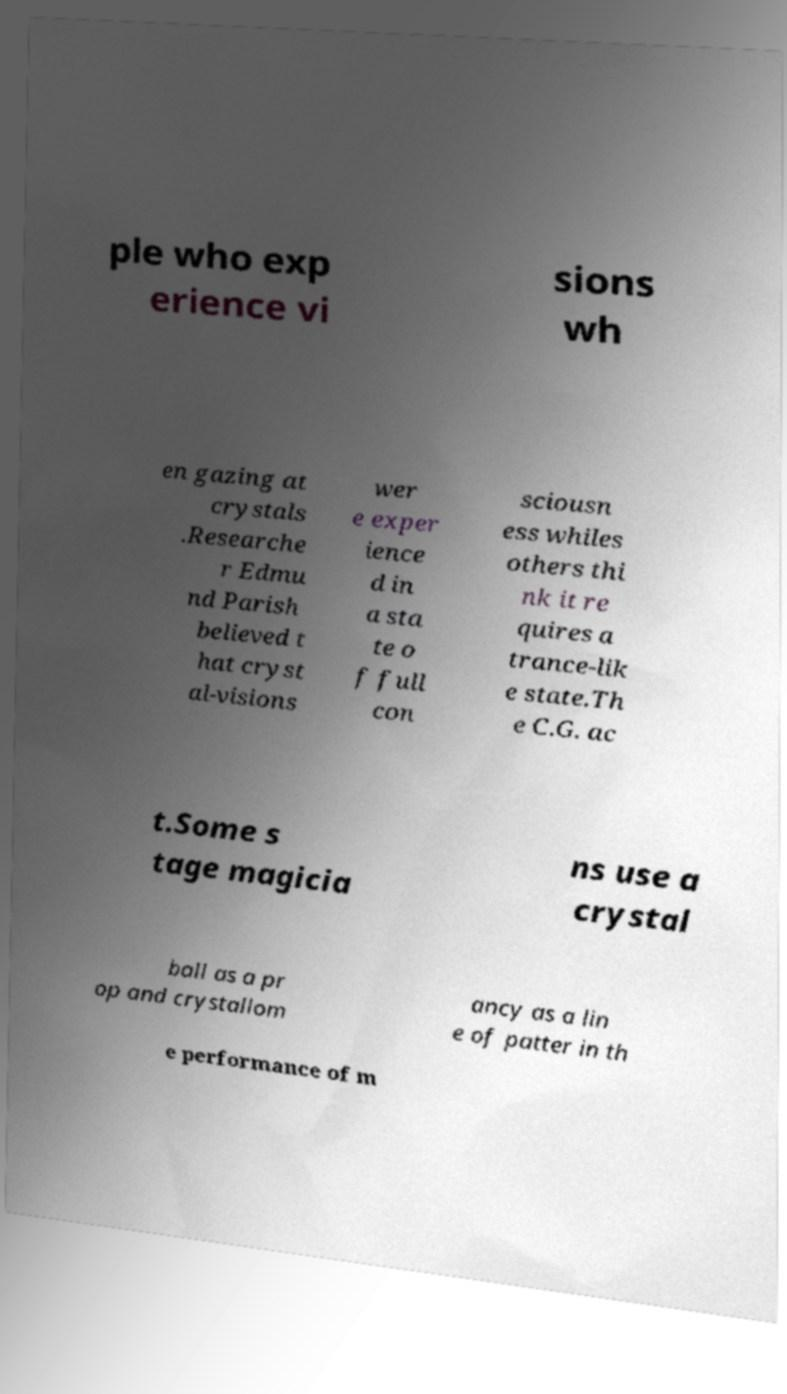Can you read and provide the text displayed in the image?This photo seems to have some interesting text. Can you extract and type it out for me? ple who exp erience vi sions wh en gazing at crystals .Researche r Edmu nd Parish believed t hat cryst al-visions wer e exper ience d in a sta te o f full con sciousn ess whiles others thi nk it re quires a trance-lik e state.Th e C.G. ac t.Some s tage magicia ns use a crystal ball as a pr op and crystallom ancy as a lin e of patter in th e performance of m 